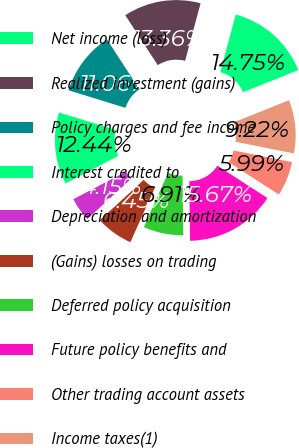Convert chart. <chart><loc_0><loc_0><loc_500><loc_500><pie_chart><fcel>Net income (loss)<fcel>Realized investment (gains)<fcel>Policy charges and fee income<fcel>Interest credited to<fcel>Depreciation and amortization<fcel>(Gains) losses on trading<fcel>Deferred policy acquisition<fcel>Future policy benefits and<fcel>Other trading account assets<fcel>Income taxes(1)<nl><fcel>14.75%<fcel>13.36%<fcel>11.06%<fcel>12.44%<fcel>4.15%<fcel>6.45%<fcel>6.91%<fcel>15.67%<fcel>5.99%<fcel>9.22%<nl></chart> 